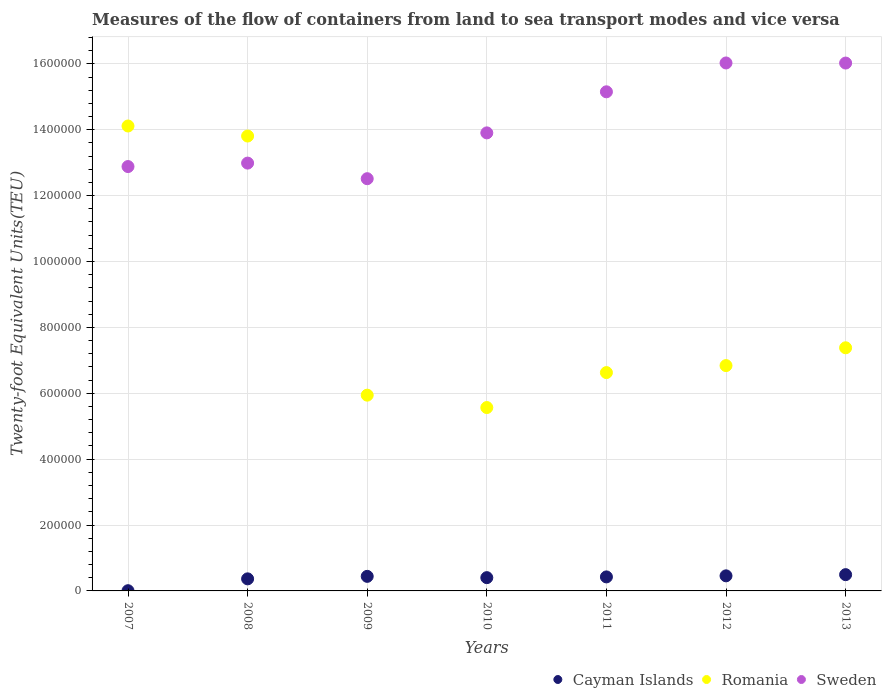Is the number of dotlines equal to the number of legend labels?
Make the answer very short. Yes. What is the container port traffic in Romania in 2012?
Provide a succinct answer. 6.84e+05. Across all years, what is the maximum container port traffic in Sweden?
Keep it short and to the point. 1.60e+06. Across all years, what is the minimum container port traffic in Sweden?
Offer a very short reply. 1.25e+06. In which year was the container port traffic in Sweden maximum?
Your response must be concise. 2012. What is the total container port traffic in Romania in the graph?
Offer a terse response. 6.03e+06. What is the difference between the container port traffic in Sweden in 2007 and that in 2008?
Your answer should be compact. -1.05e+04. What is the difference between the container port traffic in Cayman Islands in 2007 and the container port traffic in Romania in 2009?
Provide a short and direct response. -5.94e+05. What is the average container port traffic in Cayman Islands per year?
Ensure brevity in your answer.  3.71e+04. In the year 2007, what is the difference between the container port traffic in Sweden and container port traffic in Romania?
Offer a very short reply. -1.23e+05. What is the ratio of the container port traffic in Romania in 2007 to that in 2009?
Offer a terse response. 2.37. Is the container port traffic in Cayman Islands in 2009 less than that in 2011?
Your answer should be compact. No. What is the difference between the highest and the second highest container port traffic in Cayman Islands?
Make the answer very short. 3615.85. What is the difference between the highest and the lowest container port traffic in Sweden?
Your answer should be very brief. 3.51e+05. Is the sum of the container port traffic in Romania in 2009 and 2010 greater than the maximum container port traffic in Cayman Islands across all years?
Provide a short and direct response. Yes. Is it the case that in every year, the sum of the container port traffic in Romania and container port traffic in Cayman Islands  is greater than the container port traffic in Sweden?
Offer a very short reply. No. Does the container port traffic in Cayman Islands monotonically increase over the years?
Your response must be concise. No. Is the container port traffic in Cayman Islands strictly greater than the container port traffic in Romania over the years?
Make the answer very short. No. Is the container port traffic in Cayman Islands strictly less than the container port traffic in Sweden over the years?
Offer a terse response. Yes. How many dotlines are there?
Your answer should be very brief. 3. What is the difference between two consecutive major ticks on the Y-axis?
Offer a very short reply. 2.00e+05. Are the values on the major ticks of Y-axis written in scientific E-notation?
Your answer should be very brief. No. What is the title of the graph?
Keep it short and to the point. Measures of the flow of containers from land to sea transport modes and vice versa. What is the label or title of the X-axis?
Keep it short and to the point. Years. What is the label or title of the Y-axis?
Offer a terse response. Twenty-foot Equivalent Units(TEU). What is the Twenty-foot Equivalent Units(TEU) of Cayman Islands in 2007?
Provide a short and direct response. 649. What is the Twenty-foot Equivalent Units(TEU) in Romania in 2007?
Make the answer very short. 1.41e+06. What is the Twenty-foot Equivalent Units(TEU) of Sweden in 2007?
Ensure brevity in your answer.  1.29e+06. What is the Twenty-foot Equivalent Units(TEU) in Cayman Islands in 2008?
Make the answer very short. 3.66e+04. What is the Twenty-foot Equivalent Units(TEU) of Romania in 2008?
Your response must be concise. 1.38e+06. What is the Twenty-foot Equivalent Units(TEU) of Sweden in 2008?
Give a very brief answer. 1.30e+06. What is the Twenty-foot Equivalent Units(TEU) of Cayman Islands in 2009?
Offer a terse response. 4.42e+04. What is the Twenty-foot Equivalent Units(TEU) in Romania in 2009?
Your answer should be compact. 5.94e+05. What is the Twenty-foot Equivalent Units(TEU) of Sweden in 2009?
Your answer should be very brief. 1.25e+06. What is the Twenty-foot Equivalent Units(TEU) in Cayman Islands in 2010?
Offer a terse response. 4.03e+04. What is the Twenty-foot Equivalent Units(TEU) of Romania in 2010?
Provide a short and direct response. 5.57e+05. What is the Twenty-foot Equivalent Units(TEU) of Sweden in 2010?
Offer a terse response. 1.39e+06. What is the Twenty-foot Equivalent Units(TEU) in Cayman Islands in 2011?
Make the answer very short. 4.26e+04. What is the Twenty-foot Equivalent Units(TEU) of Romania in 2011?
Offer a terse response. 6.63e+05. What is the Twenty-foot Equivalent Units(TEU) of Sweden in 2011?
Offer a terse response. 1.52e+06. What is the Twenty-foot Equivalent Units(TEU) of Cayman Islands in 2012?
Keep it short and to the point. 4.58e+04. What is the Twenty-foot Equivalent Units(TEU) in Romania in 2012?
Give a very brief answer. 6.84e+05. What is the Twenty-foot Equivalent Units(TEU) of Sweden in 2012?
Your answer should be very brief. 1.60e+06. What is the Twenty-foot Equivalent Units(TEU) in Cayman Islands in 2013?
Ensure brevity in your answer.  4.94e+04. What is the Twenty-foot Equivalent Units(TEU) of Romania in 2013?
Your response must be concise. 7.38e+05. What is the Twenty-foot Equivalent Units(TEU) of Sweden in 2013?
Provide a short and direct response. 1.60e+06. Across all years, what is the maximum Twenty-foot Equivalent Units(TEU) of Cayman Islands?
Keep it short and to the point. 4.94e+04. Across all years, what is the maximum Twenty-foot Equivalent Units(TEU) in Romania?
Offer a terse response. 1.41e+06. Across all years, what is the maximum Twenty-foot Equivalent Units(TEU) of Sweden?
Offer a very short reply. 1.60e+06. Across all years, what is the minimum Twenty-foot Equivalent Units(TEU) in Cayman Islands?
Ensure brevity in your answer.  649. Across all years, what is the minimum Twenty-foot Equivalent Units(TEU) in Romania?
Give a very brief answer. 5.57e+05. Across all years, what is the minimum Twenty-foot Equivalent Units(TEU) in Sweden?
Offer a very short reply. 1.25e+06. What is the total Twenty-foot Equivalent Units(TEU) of Cayman Islands in the graph?
Ensure brevity in your answer.  2.60e+05. What is the total Twenty-foot Equivalent Units(TEU) of Romania in the graph?
Your answer should be very brief. 6.03e+06. What is the total Twenty-foot Equivalent Units(TEU) in Sweden in the graph?
Provide a short and direct response. 9.95e+06. What is the difference between the Twenty-foot Equivalent Units(TEU) in Cayman Islands in 2007 and that in 2008?
Offer a very short reply. -3.60e+04. What is the difference between the Twenty-foot Equivalent Units(TEU) in Romania in 2007 and that in 2008?
Keep it short and to the point. 3.05e+04. What is the difference between the Twenty-foot Equivalent Units(TEU) of Sweden in 2007 and that in 2008?
Offer a terse response. -1.05e+04. What is the difference between the Twenty-foot Equivalent Units(TEU) of Cayman Islands in 2007 and that in 2009?
Your answer should be compact. -4.36e+04. What is the difference between the Twenty-foot Equivalent Units(TEU) of Romania in 2007 and that in 2009?
Your answer should be very brief. 8.17e+05. What is the difference between the Twenty-foot Equivalent Units(TEU) in Sweden in 2007 and that in 2009?
Offer a terse response. 3.69e+04. What is the difference between the Twenty-foot Equivalent Units(TEU) in Cayman Islands in 2007 and that in 2010?
Offer a very short reply. -3.96e+04. What is the difference between the Twenty-foot Equivalent Units(TEU) in Romania in 2007 and that in 2010?
Provide a succinct answer. 8.55e+05. What is the difference between the Twenty-foot Equivalent Units(TEU) of Sweden in 2007 and that in 2010?
Make the answer very short. -1.02e+05. What is the difference between the Twenty-foot Equivalent Units(TEU) of Cayman Islands in 2007 and that in 2011?
Give a very brief answer. -4.19e+04. What is the difference between the Twenty-foot Equivalent Units(TEU) in Romania in 2007 and that in 2011?
Keep it short and to the point. 7.49e+05. What is the difference between the Twenty-foot Equivalent Units(TEU) in Sweden in 2007 and that in 2011?
Keep it short and to the point. -2.27e+05. What is the difference between the Twenty-foot Equivalent Units(TEU) of Cayman Islands in 2007 and that in 2012?
Make the answer very short. -4.51e+04. What is the difference between the Twenty-foot Equivalent Units(TEU) in Romania in 2007 and that in 2012?
Your response must be concise. 7.27e+05. What is the difference between the Twenty-foot Equivalent Units(TEU) of Sweden in 2007 and that in 2012?
Provide a short and direct response. -3.14e+05. What is the difference between the Twenty-foot Equivalent Units(TEU) of Cayman Islands in 2007 and that in 2013?
Your answer should be compact. -4.87e+04. What is the difference between the Twenty-foot Equivalent Units(TEU) in Romania in 2007 and that in 2013?
Your answer should be compact. 6.73e+05. What is the difference between the Twenty-foot Equivalent Units(TEU) in Sweden in 2007 and that in 2013?
Give a very brief answer. -3.14e+05. What is the difference between the Twenty-foot Equivalent Units(TEU) in Cayman Islands in 2008 and that in 2009?
Make the answer very short. -7571. What is the difference between the Twenty-foot Equivalent Units(TEU) of Romania in 2008 and that in 2009?
Make the answer very short. 7.87e+05. What is the difference between the Twenty-foot Equivalent Units(TEU) in Sweden in 2008 and that in 2009?
Provide a succinct answer. 4.74e+04. What is the difference between the Twenty-foot Equivalent Units(TEU) of Cayman Islands in 2008 and that in 2010?
Your response must be concise. -3637. What is the difference between the Twenty-foot Equivalent Units(TEU) in Romania in 2008 and that in 2010?
Offer a terse response. 8.24e+05. What is the difference between the Twenty-foot Equivalent Units(TEU) of Sweden in 2008 and that in 2010?
Keep it short and to the point. -9.17e+04. What is the difference between the Twenty-foot Equivalent Units(TEU) of Cayman Islands in 2008 and that in 2011?
Offer a very short reply. -5933. What is the difference between the Twenty-foot Equivalent Units(TEU) of Romania in 2008 and that in 2011?
Give a very brief answer. 7.18e+05. What is the difference between the Twenty-foot Equivalent Units(TEU) in Sweden in 2008 and that in 2011?
Your answer should be compact. -2.16e+05. What is the difference between the Twenty-foot Equivalent Units(TEU) in Cayman Islands in 2008 and that in 2012?
Keep it short and to the point. -9126.27. What is the difference between the Twenty-foot Equivalent Units(TEU) in Romania in 2008 and that in 2012?
Give a very brief answer. 6.97e+05. What is the difference between the Twenty-foot Equivalent Units(TEU) in Sweden in 2008 and that in 2012?
Keep it short and to the point. -3.04e+05. What is the difference between the Twenty-foot Equivalent Units(TEU) in Cayman Islands in 2008 and that in 2013?
Keep it short and to the point. -1.27e+04. What is the difference between the Twenty-foot Equivalent Units(TEU) in Romania in 2008 and that in 2013?
Your answer should be compact. 6.43e+05. What is the difference between the Twenty-foot Equivalent Units(TEU) of Sweden in 2008 and that in 2013?
Make the answer very short. -3.04e+05. What is the difference between the Twenty-foot Equivalent Units(TEU) in Cayman Islands in 2009 and that in 2010?
Provide a short and direct response. 3934. What is the difference between the Twenty-foot Equivalent Units(TEU) in Romania in 2009 and that in 2010?
Offer a terse response. 3.76e+04. What is the difference between the Twenty-foot Equivalent Units(TEU) in Sweden in 2009 and that in 2010?
Provide a short and direct response. -1.39e+05. What is the difference between the Twenty-foot Equivalent Units(TEU) of Cayman Islands in 2009 and that in 2011?
Your answer should be compact. 1638. What is the difference between the Twenty-foot Equivalent Units(TEU) in Romania in 2009 and that in 2011?
Give a very brief answer. -6.85e+04. What is the difference between the Twenty-foot Equivalent Units(TEU) of Sweden in 2009 and that in 2011?
Provide a short and direct response. -2.64e+05. What is the difference between the Twenty-foot Equivalent Units(TEU) of Cayman Islands in 2009 and that in 2012?
Your answer should be compact. -1555.28. What is the difference between the Twenty-foot Equivalent Units(TEU) of Romania in 2009 and that in 2012?
Provide a succinct answer. -8.98e+04. What is the difference between the Twenty-foot Equivalent Units(TEU) of Sweden in 2009 and that in 2012?
Ensure brevity in your answer.  -3.51e+05. What is the difference between the Twenty-foot Equivalent Units(TEU) of Cayman Islands in 2009 and that in 2013?
Your answer should be compact. -5171.13. What is the difference between the Twenty-foot Equivalent Units(TEU) of Romania in 2009 and that in 2013?
Ensure brevity in your answer.  -1.44e+05. What is the difference between the Twenty-foot Equivalent Units(TEU) of Sweden in 2009 and that in 2013?
Your response must be concise. -3.51e+05. What is the difference between the Twenty-foot Equivalent Units(TEU) in Cayman Islands in 2010 and that in 2011?
Your answer should be very brief. -2296. What is the difference between the Twenty-foot Equivalent Units(TEU) in Romania in 2010 and that in 2011?
Offer a very short reply. -1.06e+05. What is the difference between the Twenty-foot Equivalent Units(TEU) of Sweden in 2010 and that in 2011?
Give a very brief answer. -1.25e+05. What is the difference between the Twenty-foot Equivalent Units(TEU) in Cayman Islands in 2010 and that in 2012?
Your response must be concise. -5489.27. What is the difference between the Twenty-foot Equivalent Units(TEU) in Romania in 2010 and that in 2012?
Provide a succinct answer. -1.27e+05. What is the difference between the Twenty-foot Equivalent Units(TEU) in Sweden in 2010 and that in 2012?
Your answer should be very brief. -2.12e+05. What is the difference between the Twenty-foot Equivalent Units(TEU) in Cayman Islands in 2010 and that in 2013?
Keep it short and to the point. -9105.13. What is the difference between the Twenty-foot Equivalent Units(TEU) of Romania in 2010 and that in 2013?
Offer a terse response. -1.81e+05. What is the difference between the Twenty-foot Equivalent Units(TEU) of Sweden in 2010 and that in 2013?
Offer a terse response. -2.12e+05. What is the difference between the Twenty-foot Equivalent Units(TEU) of Cayman Islands in 2011 and that in 2012?
Your answer should be compact. -3193.28. What is the difference between the Twenty-foot Equivalent Units(TEU) of Romania in 2011 and that in 2012?
Provide a succinct answer. -2.13e+04. What is the difference between the Twenty-foot Equivalent Units(TEU) of Sweden in 2011 and that in 2012?
Make the answer very short. -8.76e+04. What is the difference between the Twenty-foot Equivalent Units(TEU) in Cayman Islands in 2011 and that in 2013?
Provide a short and direct response. -6809.13. What is the difference between the Twenty-foot Equivalent Units(TEU) of Romania in 2011 and that in 2013?
Give a very brief answer. -7.53e+04. What is the difference between the Twenty-foot Equivalent Units(TEU) of Sweden in 2011 and that in 2013?
Make the answer very short. -8.73e+04. What is the difference between the Twenty-foot Equivalent Units(TEU) of Cayman Islands in 2012 and that in 2013?
Your response must be concise. -3615.85. What is the difference between the Twenty-foot Equivalent Units(TEU) in Romania in 2012 and that in 2013?
Keep it short and to the point. -5.40e+04. What is the difference between the Twenty-foot Equivalent Units(TEU) in Sweden in 2012 and that in 2013?
Offer a terse response. 302.98. What is the difference between the Twenty-foot Equivalent Units(TEU) of Cayman Islands in 2007 and the Twenty-foot Equivalent Units(TEU) of Romania in 2008?
Make the answer very short. -1.38e+06. What is the difference between the Twenty-foot Equivalent Units(TEU) in Cayman Islands in 2007 and the Twenty-foot Equivalent Units(TEU) in Sweden in 2008?
Give a very brief answer. -1.30e+06. What is the difference between the Twenty-foot Equivalent Units(TEU) of Romania in 2007 and the Twenty-foot Equivalent Units(TEU) of Sweden in 2008?
Keep it short and to the point. 1.13e+05. What is the difference between the Twenty-foot Equivalent Units(TEU) in Cayman Islands in 2007 and the Twenty-foot Equivalent Units(TEU) in Romania in 2009?
Make the answer very short. -5.94e+05. What is the difference between the Twenty-foot Equivalent Units(TEU) of Cayman Islands in 2007 and the Twenty-foot Equivalent Units(TEU) of Sweden in 2009?
Provide a short and direct response. -1.25e+06. What is the difference between the Twenty-foot Equivalent Units(TEU) in Romania in 2007 and the Twenty-foot Equivalent Units(TEU) in Sweden in 2009?
Offer a very short reply. 1.60e+05. What is the difference between the Twenty-foot Equivalent Units(TEU) in Cayman Islands in 2007 and the Twenty-foot Equivalent Units(TEU) in Romania in 2010?
Your answer should be very brief. -5.56e+05. What is the difference between the Twenty-foot Equivalent Units(TEU) in Cayman Islands in 2007 and the Twenty-foot Equivalent Units(TEU) in Sweden in 2010?
Your answer should be very brief. -1.39e+06. What is the difference between the Twenty-foot Equivalent Units(TEU) in Romania in 2007 and the Twenty-foot Equivalent Units(TEU) in Sweden in 2010?
Your response must be concise. 2.09e+04. What is the difference between the Twenty-foot Equivalent Units(TEU) of Cayman Islands in 2007 and the Twenty-foot Equivalent Units(TEU) of Romania in 2011?
Offer a very short reply. -6.62e+05. What is the difference between the Twenty-foot Equivalent Units(TEU) in Cayman Islands in 2007 and the Twenty-foot Equivalent Units(TEU) in Sweden in 2011?
Give a very brief answer. -1.51e+06. What is the difference between the Twenty-foot Equivalent Units(TEU) in Romania in 2007 and the Twenty-foot Equivalent Units(TEU) in Sweden in 2011?
Your answer should be compact. -1.04e+05. What is the difference between the Twenty-foot Equivalent Units(TEU) in Cayman Islands in 2007 and the Twenty-foot Equivalent Units(TEU) in Romania in 2012?
Provide a short and direct response. -6.83e+05. What is the difference between the Twenty-foot Equivalent Units(TEU) of Cayman Islands in 2007 and the Twenty-foot Equivalent Units(TEU) of Sweden in 2012?
Provide a short and direct response. -1.60e+06. What is the difference between the Twenty-foot Equivalent Units(TEU) of Romania in 2007 and the Twenty-foot Equivalent Units(TEU) of Sweden in 2012?
Your response must be concise. -1.91e+05. What is the difference between the Twenty-foot Equivalent Units(TEU) of Cayman Islands in 2007 and the Twenty-foot Equivalent Units(TEU) of Romania in 2013?
Provide a succinct answer. -7.37e+05. What is the difference between the Twenty-foot Equivalent Units(TEU) of Cayman Islands in 2007 and the Twenty-foot Equivalent Units(TEU) of Sweden in 2013?
Offer a very short reply. -1.60e+06. What is the difference between the Twenty-foot Equivalent Units(TEU) of Romania in 2007 and the Twenty-foot Equivalent Units(TEU) of Sweden in 2013?
Provide a succinct answer. -1.91e+05. What is the difference between the Twenty-foot Equivalent Units(TEU) of Cayman Islands in 2008 and the Twenty-foot Equivalent Units(TEU) of Romania in 2009?
Offer a very short reply. -5.58e+05. What is the difference between the Twenty-foot Equivalent Units(TEU) in Cayman Islands in 2008 and the Twenty-foot Equivalent Units(TEU) in Sweden in 2009?
Offer a terse response. -1.21e+06. What is the difference between the Twenty-foot Equivalent Units(TEU) in Romania in 2008 and the Twenty-foot Equivalent Units(TEU) in Sweden in 2009?
Make the answer very short. 1.30e+05. What is the difference between the Twenty-foot Equivalent Units(TEU) of Cayman Islands in 2008 and the Twenty-foot Equivalent Units(TEU) of Romania in 2010?
Your answer should be compact. -5.20e+05. What is the difference between the Twenty-foot Equivalent Units(TEU) in Cayman Islands in 2008 and the Twenty-foot Equivalent Units(TEU) in Sweden in 2010?
Your response must be concise. -1.35e+06. What is the difference between the Twenty-foot Equivalent Units(TEU) in Romania in 2008 and the Twenty-foot Equivalent Units(TEU) in Sweden in 2010?
Provide a short and direct response. -9569. What is the difference between the Twenty-foot Equivalent Units(TEU) of Cayman Islands in 2008 and the Twenty-foot Equivalent Units(TEU) of Romania in 2011?
Your response must be concise. -6.26e+05. What is the difference between the Twenty-foot Equivalent Units(TEU) of Cayman Islands in 2008 and the Twenty-foot Equivalent Units(TEU) of Sweden in 2011?
Your response must be concise. -1.48e+06. What is the difference between the Twenty-foot Equivalent Units(TEU) of Romania in 2008 and the Twenty-foot Equivalent Units(TEU) of Sweden in 2011?
Offer a very short reply. -1.34e+05. What is the difference between the Twenty-foot Equivalent Units(TEU) in Cayman Islands in 2008 and the Twenty-foot Equivalent Units(TEU) in Romania in 2012?
Ensure brevity in your answer.  -6.47e+05. What is the difference between the Twenty-foot Equivalent Units(TEU) of Cayman Islands in 2008 and the Twenty-foot Equivalent Units(TEU) of Sweden in 2012?
Make the answer very short. -1.57e+06. What is the difference between the Twenty-foot Equivalent Units(TEU) in Romania in 2008 and the Twenty-foot Equivalent Units(TEU) in Sweden in 2012?
Offer a very short reply. -2.22e+05. What is the difference between the Twenty-foot Equivalent Units(TEU) of Cayman Islands in 2008 and the Twenty-foot Equivalent Units(TEU) of Romania in 2013?
Your answer should be compact. -7.01e+05. What is the difference between the Twenty-foot Equivalent Units(TEU) of Cayman Islands in 2008 and the Twenty-foot Equivalent Units(TEU) of Sweden in 2013?
Give a very brief answer. -1.57e+06. What is the difference between the Twenty-foot Equivalent Units(TEU) of Romania in 2008 and the Twenty-foot Equivalent Units(TEU) of Sweden in 2013?
Your answer should be very brief. -2.22e+05. What is the difference between the Twenty-foot Equivalent Units(TEU) of Cayman Islands in 2009 and the Twenty-foot Equivalent Units(TEU) of Romania in 2010?
Ensure brevity in your answer.  -5.12e+05. What is the difference between the Twenty-foot Equivalent Units(TEU) in Cayman Islands in 2009 and the Twenty-foot Equivalent Units(TEU) in Sweden in 2010?
Your response must be concise. -1.35e+06. What is the difference between the Twenty-foot Equivalent Units(TEU) of Romania in 2009 and the Twenty-foot Equivalent Units(TEU) of Sweden in 2010?
Ensure brevity in your answer.  -7.96e+05. What is the difference between the Twenty-foot Equivalent Units(TEU) of Cayman Islands in 2009 and the Twenty-foot Equivalent Units(TEU) of Romania in 2011?
Offer a terse response. -6.19e+05. What is the difference between the Twenty-foot Equivalent Units(TEU) of Cayman Islands in 2009 and the Twenty-foot Equivalent Units(TEU) of Sweden in 2011?
Your answer should be compact. -1.47e+06. What is the difference between the Twenty-foot Equivalent Units(TEU) in Romania in 2009 and the Twenty-foot Equivalent Units(TEU) in Sweden in 2011?
Ensure brevity in your answer.  -9.21e+05. What is the difference between the Twenty-foot Equivalent Units(TEU) of Cayman Islands in 2009 and the Twenty-foot Equivalent Units(TEU) of Romania in 2012?
Offer a terse response. -6.40e+05. What is the difference between the Twenty-foot Equivalent Units(TEU) of Cayman Islands in 2009 and the Twenty-foot Equivalent Units(TEU) of Sweden in 2012?
Make the answer very short. -1.56e+06. What is the difference between the Twenty-foot Equivalent Units(TEU) in Romania in 2009 and the Twenty-foot Equivalent Units(TEU) in Sweden in 2012?
Ensure brevity in your answer.  -1.01e+06. What is the difference between the Twenty-foot Equivalent Units(TEU) in Cayman Islands in 2009 and the Twenty-foot Equivalent Units(TEU) in Romania in 2013?
Give a very brief answer. -6.94e+05. What is the difference between the Twenty-foot Equivalent Units(TEU) of Cayman Islands in 2009 and the Twenty-foot Equivalent Units(TEU) of Sweden in 2013?
Make the answer very short. -1.56e+06. What is the difference between the Twenty-foot Equivalent Units(TEU) of Romania in 2009 and the Twenty-foot Equivalent Units(TEU) of Sweden in 2013?
Provide a succinct answer. -1.01e+06. What is the difference between the Twenty-foot Equivalent Units(TEU) in Cayman Islands in 2010 and the Twenty-foot Equivalent Units(TEU) in Romania in 2011?
Give a very brief answer. -6.23e+05. What is the difference between the Twenty-foot Equivalent Units(TEU) of Cayman Islands in 2010 and the Twenty-foot Equivalent Units(TEU) of Sweden in 2011?
Your answer should be very brief. -1.47e+06. What is the difference between the Twenty-foot Equivalent Units(TEU) of Romania in 2010 and the Twenty-foot Equivalent Units(TEU) of Sweden in 2011?
Make the answer very short. -9.59e+05. What is the difference between the Twenty-foot Equivalent Units(TEU) of Cayman Islands in 2010 and the Twenty-foot Equivalent Units(TEU) of Romania in 2012?
Make the answer very short. -6.44e+05. What is the difference between the Twenty-foot Equivalent Units(TEU) of Cayman Islands in 2010 and the Twenty-foot Equivalent Units(TEU) of Sweden in 2012?
Keep it short and to the point. -1.56e+06. What is the difference between the Twenty-foot Equivalent Units(TEU) in Romania in 2010 and the Twenty-foot Equivalent Units(TEU) in Sweden in 2012?
Offer a very short reply. -1.05e+06. What is the difference between the Twenty-foot Equivalent Units(TEU) in Cayman Islands in 2010 and the Twenty-foot Equivalent Units(TEU) in Romania in 2013?
Your response must be concise. -6.98e+05. What is the difference between the Twenty-foot Equivalent Units(TEU) in Cayman Islands in 2010 and the Twenty-foot Equivalent Units(TEU) in Sweden in 2013?
Make the answer very short. -1.56e+06. What is the difference between the Twenty-foot Equivalent Units(TEU) of Romania in 2010 and the Twenty-foot Equivalent Units(TEU) of Sweden in 2013?
Your answer should be very brief. -1.05e+06. What is the difference between the Twenty-foot Equivalent Units(TEU) of Cayman Islands in 2011 and the Twenty-foot Equivalent Units(TEU) of Romania in 2012?
Your answer should be compact. -6.41e+05. What is the difference between the Twenty-foot Equivalent Units(TEU) in Cayman Islands in 2011 and the Twenty-foot Equivalent Units(TEU) in Sweden in 2012?
Your answer should be compact. -1.56e+06. What is the difference between the Twenty-foot Equivalent Units(TEU) in Romania in 2011 and the Twenty-foot Equivalent Units(TEU) in Sweden in 2012?
Keep it short and to the point. -9.40e+05. What is the difference between the Twenty-foot Equivalent Units(TEU) in Cayman Islands in 2011 and the Twenty-foot Equivalent Units(TEU) in Romania in 2013?
Your answer should be very brief. -6.96e+05. What is the difference between the Twenty-foot Equivalent Units(TEU) in Cayman Islands in 2011 and the Twenty-foot Equivalent Units(TEU) in Sweden in 2013?
Your response must be concise. -1.56e+06. What is the difference between the Twenty-foot Equivalent Units(TEU) in Romania in 2011 and the Twenty-foot Equivalent Units(TEU) in Sweden in 2013?
Your response must be concise. -9.40e+05. What is the difference between the Twenty-foot Equivalent Units(TEU) of Cayman Islands in 2012 and the Twenty-foot Equivalent Units(TEU) of Romania in 2013?
Ensure brevity in your answer.  -6.92e+05. What is the difference between the Twenty-foot Equivalent Units(TEU) of Cayman Islands in 2012 and the Twenty-foot Equivalent Units(TEU) of Sweden in 2013?
Keep it short and to the point. -1.56e+06. What is the difference between the Twenty-foot Equivalent Units(TEU) of Romania in 2012 and the Twenty-foot Equivalent Units(TEU) of Sweden in 2013?
Offer a very short reply. -9.18e+05. What is the average Twenty-foot Equivalent Units(TEU) of Cayman Islands per year?
Your answer should be very brief. 3.71e+04. What is the average Twenty-foot Equivalent Units(TEU) in Romania per year?
Offer a very short reply. 8.61e+05. What is the average Twenty-foot Equivalent Units(TEU) of Sweden per year?
Your response must be concise. 1.42e+06. In the year 2007, what is the difference between the Twenty-foot Equivalent Units(TEU) of Cayman Islands and Twenty-foot Equivalent Units(TEU) of Romania?
Keep it short and to the point. -1.41e+06. In the year 2007, what is the difference between the Twenty-foot Equivalent Units(TEU) of Cayman Islands and Twenty-foot Equivalent Units(TEU) of Sweden?
Provide a succinct answer. -1.29e+06. In the year 2007, what is the difference between the Twenty-foot Equivalent Units(TEU) of Romania and Twenty-foot Equivalent Units(TEU) of Sweden?
Give a very brief answer. 1.23e+05. In the year 2008, what is the difference between the Twenty-foot Equivalent Units(TEU) in Cayman Islands and Twenty-foot Equivalent Units(TEU) in Romania?
Provide a short and direct response. -1.34e+06. In the year 2008, what is the difference between the Twenty-foot Equivalent Units(TEU) of Cayman Islands and Twenty-foot Equivalent Units(TEU) of Sweden?
Ensure brevity in your answer.  -1.26e+06. In the year 2008, what is the difference between the Twenty-foot Equivalent Units(TEU) of Romania and Twenty-foot Equivalent Units(TEU) of Sweden?
Your response must be concise. 8.22e+04. In the year 2009, what is the difference between the Twenty-foot Equivalent Units(TEU) in Cayman Islands and Twenty-foot Equivalent Units(TEU) in Romania?
Your answer should be compact. -5.50e+05. In the year 2009, what is the difference between the Twenty-foot Equivalent Units(TEU) in Cayman Islands and Twenty-foot Equivalent Units(TEU) in Sweden?
Give a very brief answer. -1.21e+06. In the year 2009, what is the difference between the Twenty-foot Equivalent Units(TEU) in Romania and Twenty-foot Equivalent Units(TEU) in Sweden?
Offer a terse response. -6.57e+05. In the year 2010, what is the difference between the Twenty-foot Equivalent Units(TEU) in Cayman Islands and Twenty-foot Equivalent Units(TEU) in Romania?
Keep it short and to the point. -5.16e+05. In the year 2010, what is the difference between the Twenty-foot Equivalent Units(TEU) in Cayman Islands and Twenty-foot Equivalent Units(TEU) in Sweden?
Keep it short and to the point. -1.35e+06. In the year 2010, what is the difference between the Twenty-foot Equivalent Units(TEU) of Romania and Twenty-foot Equivalent Units(TEU) of Sweden?
Offer a terse response. -8.34e+05. In the year 2011, what is the difference between the Twenty-foot Equivalent Units(TEU) of Cayman Islands and Twenty-foot Equivalent Units(TEU) of Romania?
Ensure brevity in your answer.  -6.20e+05. In the year 2011, what is the difference between the Twenty-foot Equivalent Units(TEU) of Cayman Islands and Twenty-foot Equivalent Units(TEU) of Sweden?
Make the answer very short. -1.47e+06. In the year 2011, what is the difference between the Twenty-foot Equivalent Units(TEU) of Romania and Twenty-foot Equivalent Units(TEU) of Sweden?
Your answer should be very brief. -8.52e+05. In the year 2012, what is the difference between the Twenty-foot Equivalent Units(TEU) in Cayman Islands and Twenty-foot Equivalent Units(TEU) in Romania?
Provide a succinct answer. -6.38e+05. In the year 2012, what is the difference between the Twenty-foot Equivalent Units(TEU) of Cayman Islands and Twenty-foot Equivalent Units(TEU) of Sweden?
Offer a very short reply. -1.56e+06. In the year 2012, what is the difference between the Twenty-foot Equivalent Units(TEU) in Romania and Twenty-foot Equivalent Units(TEU) in Sweden?
Your response must be concise. -9.19e+05. In the year 2013, what is the difference between the Twenty-foot Equivalent Units(TEU) of Cayman Islands and Twenty-foot Equivalent Units(TEU) of Romania?
Offer a terse response. -6.89e+05. In the year 2013, what is the difference between the Twenty-foot Equivalent Units(TEU) of Cayman Islands and Twenty-foot Equivalent Units(TEU) of Sweden?
Keep it short and to the point. -1.55e+06. In the year 2013, what is the difference between the Twenty-foot Equivalent Units(TEU) of Romania and Twenty-foot Equivalent Units(TEU) of Sweden?
Offer a terse response. -8.64e+05. What is the ratio of the Twenty-foot Equivalent Units(TEU) in Cayman Islands in 2007 to that in 2008?
Give a very brief answer. 0.02. What is the ratio of the Twenty-foot Equivalent Units(TEU) of Romania in 2007 to that in 2008?
Offer a terse response. 1.02. What is the ratio of the Twenty-foot Equivalent Units(TEU) of Sweden in 2007 to that in 2008?
Keep it short and to the point. 0.99. What is the ratio of the Twenty-foot Equivalent Units(TEU) in Cayman Islands in 2007 to that in 2009?
Ensure brevity in your answer.  0.01. What is the ratio of the Twenty-foot Equivalent Units(TEU) of Romania in 2007 to that in 2009?
Offer a very short reply. 2.37. What is the ratio of the Twenty-foot Equivalent Units(TEU) of Sweden in 2007 to that in 2009?
Your answer should be very brief. 1.03. What is the ratio of the Twenty-foot Equivalent Units(TEU) in Cayman Islands in 2007 to that in 2010?
Offer a very short reply. 0.02. What is the ratio of the Twenty-foot Equivalent Units(TEU) in Romania in 2007 to that in 2010?
Give a very brief answer. 2.54. What is the ratio of the Twenty-foot Equivalent Units(TEU) in Sweden in 2007 to that in 2010?
Give a very brief answer. 0.93. What is the ratio of the Twenty-foot Equivalent Units(TEU) of Cayman Islands in 2007 to that in 2011?
Offer a terse response. 0.02. What is the ratio of the Twenty-foot Equivalent Units(TEU) of Romania in 2007 to that in 2011?
Give a very brief answer. 2.13. What is the ratio of the Twenty-foot Equivalent Units(TEU) of Sweden in 2007 to that in 2011?
Your answer should be very brief. 0.85. What is the ratio of the Twenty-foot Equivalent Units(TEU) of Cayman Islands in 2007 to that in 2012?
Ensure brevity in your answer.  0.01. What is the ratio of the Twenty-foot Equivalent Units(TEU) of Romania in 2007 to that in 2012?
Ensure brevity in your answer.  2.06. What is the ratio of the Twenty-foot Equivalent Units(TEU) of Sweden in 2007 to that in 2012?
Make the answer very short. 0.8. What is the ratio of the Twenty-foot Equivalent Units(TEU) in Cayman Islands in 2007 to that in 2013?
Your response must be concise. 0.01. What is the ratio of the Twenty-foot Equivalent Units(TEU) of Romania in 2007 to that in 2013?
Offer a terse response. 1.91. What is the ratio of the Twenty-foot Equivalent Units(TEU) of Sweden in 2007 to that in 2013?
Ensure brevity in your answer.  0.8. What is the ratio of the Twenty-foot Equivalent Units(TEU) of Cayman Islands in 2008 to that in 2009?
Provide a short and direct response. 0.83. What is the ratio of the Twenty-foot Equivalent Units(TEU) in Romania in 2008 to that in 2009?
Provide a succinct answer. 2.32. What is the ratio of the Twenty-foot Equivalent Units(TEU) of Sweden in 2008 to that in 2009?
Your answer should be very brief. 1.04. What is the ratio of the Twenty-foot Equivalent Units(TEU) of Cayman Islands in 2008 to that in 2010?
Keep it short and to the point. 0.91. What is the ratio of the Twenty-foot Equivalent Units(TEU) in Romania in 2008 to that in 2010?
Your answer should be very brief. 2.48. What is the ratio of the Twenty-foot Equivalent Units(TEU) of Sweden in 2008 to that in 2010?
Your response must be concise. 0.93. What is the ratio of the Twenty-foot Equivalent Units(TEU) in Cayman Islands in 2008 to that in 2011?
Keep it short and to the point. 0.86. What is the ratio of the Twenty-foot Equivalent Units(TEU) in Romania in 2008 to that in 2011?
Provide a succinct answer. 2.08. What is the ratio of the Twenty-foot Equivalent Units(TEU) in Sweden in 2008 to that in 2011?
Offer a terse response. 0.86. What is the ratio of the Twenty-foot Equivalent Units(TEU) of Cayman Islands in 2008 to that in 2012?
Keep it short and to the point. 0.8. What is the ratio of the Twenty-foot Equivalent Units(TEU) in Romania in 2008 to that in 2012?
Offer a very short reply. 2.02. What is the ratio of the Twenty-foot Equivalent Units(TEU) in Sweden in 2008 to that in 2012?
Give a very brief answer. 0.81. What is the ratio of the Twenty-foot Equivalent Units(TEU) of Cayman Islands in 2008 to that in 2013?
Give a very brief answer. 0.74. What is the ratio of the Twenty-foot Equivalent Units(TEU) of Romania in 2008 to that in 2013?
Your answer should be very brief. 1.87. What is the ratio of the Twenty-foot Equivalent Units(TEU) of Sweden in 2008 to that in 2013?
Make the answer very short. 0.81. What is the ratio of the Twenty-foot Equivalent Units(TEU) of Cayman Islands in 2009 to that in 2010?
Keep it short and to the point. 1.1. What is the ratio of the Twenty-foot Equivalent Units(TEU) in Romania in 2009 to that in 2010?
Give a very brief answer. 1.07. What is the ratio of the Twenty-foot Equivalent Units(TEU) in Romania in 2009 to that in 2011?
Keep it short and to the point. 0.9. What is the ratio of the Twenty-foot Equivalent Units(TEU) in Sweden in 2009 to that in 2011?
Offer a terse response. 0.83. What is the ratio of the Twenty-foot Equivalent Units(TEU) of Cayman Islands in 2009 to that in 2012?
Keep it short and to the point. 0.97. What is the ratio of the Twenty-foot Equivalent Units(TEU) in Romania in 2009 to that in 2012?
Your response must be concise. 0.87. What is the ratio of the Twenty-foot Equivalent Units(TEU) in Sweden in 2009 to that in 2012?
Offer a very short reply. 0.78. What is the ratio of the Twenty-foot Equivalent Units(TEU) in Cayman Islands in 2009 to that in 2013?
Provide a succinct answer. 0.9. What is the ratio of the Twenty-foot Equivalent Units(TEU) in Romania in 2009 to that in 2013?
Provide a succinct answer. 0.81. What is the ratio of the Twenty-foot Equivalent Units(TEU) in Sweden in 2009 to that in 2013?
Offer a terse response. 0.78. What is the ratio of the Twenty-foot Equivalent Units(TEU) in Cayman Islands in 2010 to that in 2011?
Keep it short and to the point. 0.95. What is the ratio of the Twenty-foot Equivalent Units(TEU) in Romania in 2010 to that in 2011?
Provide a succinct answer. 0.84. What is the ratio of the Twenty-foot Equivalent Units(TEU) in Sweden in 2010 to that in 2011?
Give a very brief answer. 0.92. What is the ratio of the Twenty-foot Equivalent Units(TEU) of Cayman Islands in 2010 to that in 2012?
Offer a terse response. 0.88. What is the ratio of the Twenty-foot Equivalent Units(TEU) of Romania in 2010 to that in 2012?
Your response must be concise. 0.81. What is the ratio of the Twenty-foot Equivalent Units(TEU) of Sweden in 2010 to that in 2012?
Your answer should be compact. 0.87. What is the ratio of the Twenty-foot Equivalent Units(TEU) in Cayman Islands in 2010 to that in 2013?
Keep it short and to the point. 0.82. What is the ratio of the Twenty-foot Equivalent Units(TEU) in Romania in 2010 to that in 2013?
Provide a short and direct response. 0.75. What is the ratio of the Twenty-foot Equivalent Units(TEU) in Sweden in 2010 to that in 2013?
Offer a terse response. 0.87. What is the ratio of the Twenty-foot Equivalent Units(TEU) in Cayman Islands in 2011 to that in 2012?
Provide a succinct answer. 0.93. What is the ratio of the Twenty-foot Equivalent Units(TEU) of Romania in 2011 to that in 2012?
Give a very brief answer. 0.97. What is the ratio of the Twenty-foot Equivalent Units(TEU) in Sweden in 2011 to that in 2012?
Offer a very short reply. 0.95. What is the ratio of the Twenty-foot Equivalent Units(TEU) in Cayman Islands in 2011 to that in 2013?
Your response must be concise. 0.86. What is the ratio of the Twenty-foot Equivalent Units(TEU) of Romania in 2011 to that in 2013?
Give a very brief answer. 0.9. What is the ratio of the Twenty-foot Equivalent Units(TEU) of Sweden in 2011 to that in 2013?
Your answer should be compact. 0.95. What is the ratio of the Twenty-foot Equivalent Units(TEU) of Cayman Islands in 2012 to that in 2013?
Provide a short and direct response. 0.93. What is the ratio of the Twenty-foot Equivalent Units(TEU) in Romania in 2012 to that in 2013?
Provide a succinct answer. 0.93. What is the ratio of the Twenty-foot Equivalent Units(TEU) in Sweden in 2012 to that in 2013?
Provide a succinct answer. 1. What is the difference between the highest and the second highest Twenty-foot Equivalent Units(TEU) in Cayman Islands?
Make the answer very short. 3615.85. What is the difference between the highest and the second highest Twenty-foot Equivalent Units(TEU) in Romania?
Make the answer very short. 3.05e+04. What is the difference between the highest and the second highest Twenty-foot Equivalent Units(TEU) in Sweden?
Provide a short and direct response. 302.98. What is the difference between the highest and the lowest Twenty-foot Equivalent Units(TEU) in Cayman Islands?
Offer a terse response. 4.87e+04. What is the difference between the highest and the lowest Twenty-foot Equivalent Units(TEU) of Romania?
Your answer should be compact. 8.55e+05. What is the difference between the highest and the lowest Twenty-foot Equivalent Units(TEU) of Sweden?
Your answer should be very brief. 3.51e+05. 